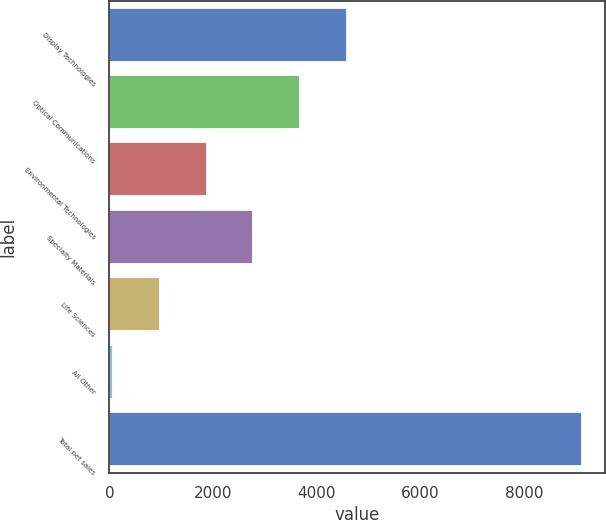<chart> <loc_0><loc_0><loc_500><loc_500><bar_chart><fcel>Display Technologies<fcel>Optical Communications<fcel>Environmental Technologies<fcel>Specialty Materials<fcel>Life Sciences<fcel>All Other<fcel>Total net sales<nl><fcel>4587.5<fcel>3682.8<fcel>1873.4<fcel>2778.1<fcel>968.7<fcel>64<fcel>9111<nl></chart> 